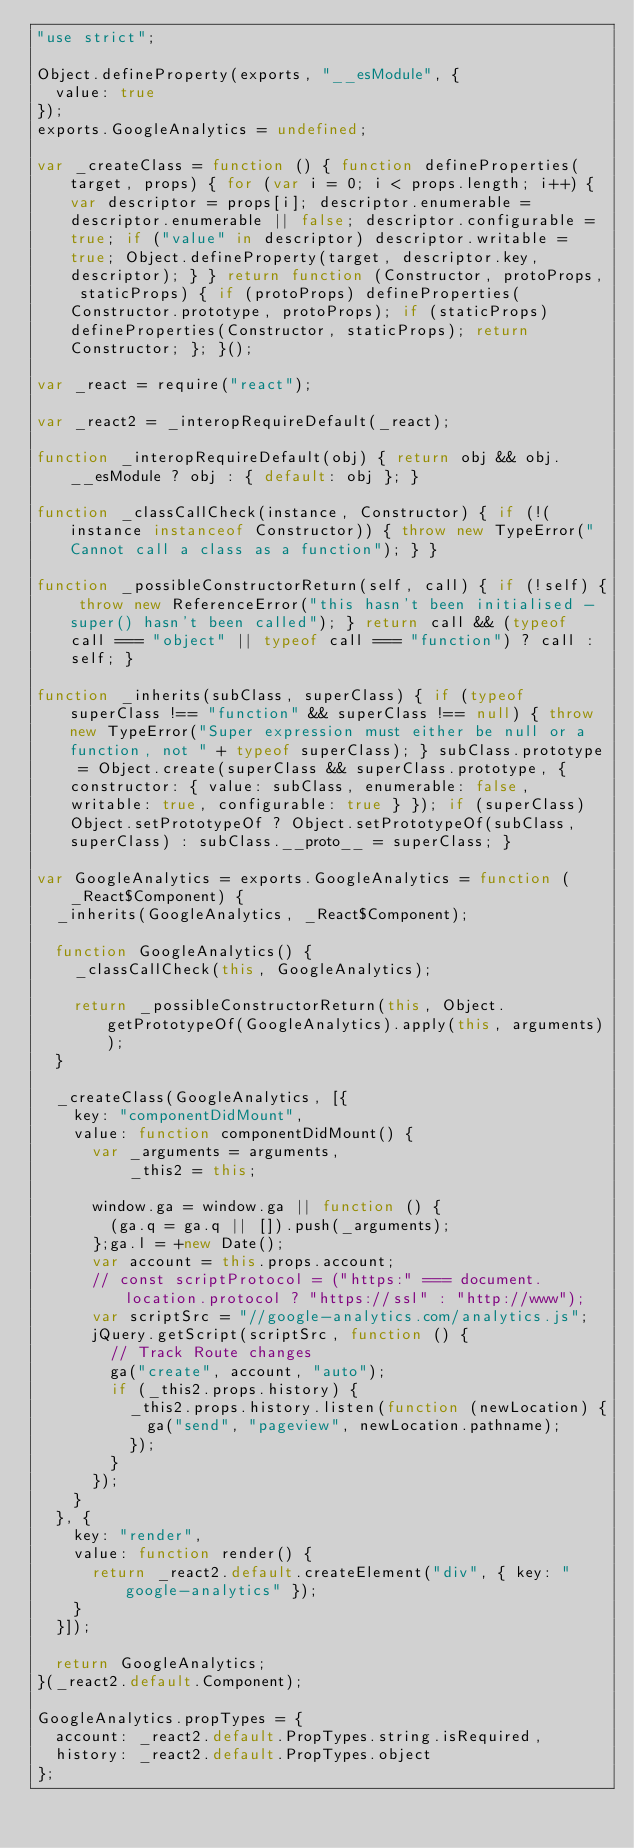<code> <loc_0><loc_0><loc_500><loc_500><_JavaScript_>"use strict";

Object.defineProperty(exports, "__esModule", {
  value: true
});
exports.GoogleAnalytics = undefined;

var _createClass = function () { function defineProperties(target, props) { for (var i = 0; i < props.length; i++) { var descriptor = props[i]; descriptor.enumerable = descriptor.enumerable || false; descriptor.configurable = true; if ("value" in descriptor) descriptor.writable = true; Object.defineProperty(target, descriptor.key, descriptor); } } return function (Constructor, protoProps, staticProps) { if (protoProps) defineProperties(Constructor.prototype, protoProps); if (staticProps) defineProperties(Constructor, staticProps); return Constructor; }; }();

var _react = require("react");

var _react2 = _interopRequireDefault(_react);

function _interopRequireDefault(obj) { return obj && obj.__esModule ? obj : { default: obj }; }

function _classCallCheck(instance, Constructor) { if (!(instance instanceof Constructor)) { throw new TypeError("Cannot call a class as a function"); } }

function _possibleConstructorReturn(self, call) { if (!self) { throw new ReferenceError("this hasn't been initialised - super() hasn't been called"); } return call && (typeof call === "object" || typeof call === "function") ? call : self; }

function _inherits(subClass, superClass) { if (typeof superClass !== "function" && superClass !== null) { throw new TypeError("Super expression must either be null or a function, not " + typeof superClass); } subClass.prototype = Object.create(superClass && superClass.prototype, { constructor: { value: subClass, enumerable: false, writable: true, configurable: true } }); if (superClass) Object.setPrototypeOf ? Object.setPrototypeOf(subClass, superClass) : subClass.__proto__ = superClass; }

var GoogleAnalytics = exports.GoogleAnalytics = function (_React$Component) {
  _inherits(GoogleAnalytics, _React$Component);

  function GoogleAnalytics() {
    _classCallCheck(this, GoogleAnalytics);

    return _possibleConstructorReturn(this, Object.getPrototypeOf(GoogleAnalytics).apply(this, arguments));
  }

  _createClass(GoogleAnalytics, [{
    key: "componentDidMount",
    value: function componentDidMount() {
      var _arguments = arguments,
          _this2 = this;

      window.ga = window.ga || function () {
        (ga.q = ga.q || []).push(_arguments);
      };ga.l = +new Date();
      var account = this.props.account;
      // const scriptProtocol = ("https:" === document.location.protocol ? "https://ssl" : "http://www");
      var scriptSrc = "//google-analytics.com/analytics.js";
      jQuery.getScript(scriptSrc, function () {
        // Track Route changes
        ga("create", account, "auto");
        if (_this2.props.history) {
          _this2.props.history.listen(function (newLocation) {
            ga("send", "pageview", newLocation.pathname);
          });
        }
      });
    }
  }, {
    key: "render",
    value: function render() {
      return _react2.default.createElement("div", { key: "google-analytics" });
    }
  }]);

  return GoogleAnalytics;
}(_react2.default.Component);

GoogleAnalytics.propTypes = {
  account: _react2.default.PropTypes.string.isRequired,
  history: _react2.default.PropTypes.object
};</code> 